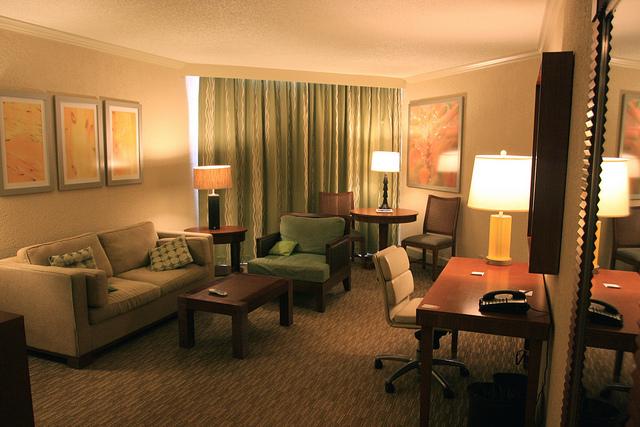Is the room empty?
Short answer required. Yes. What type of room is this?
Give a very brief answer. Living room. Are the window curtains open?
Give a very brief answer. No. 